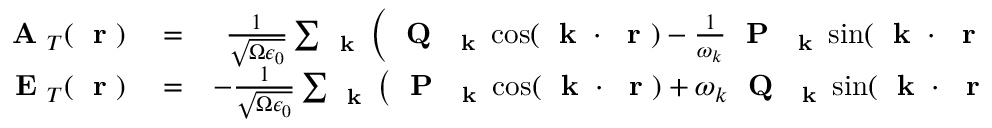Convert formula to latex. <formula><loc_0><loc_0><loc_500><loc_500>\begin{array} { r l r } { A _ { T } ( r ) } & = } & { \frac { 1 } { \sqrt { \Omega \epsilon _ { 0 } } } \sum _ { k } \left ( Q _ { k } \cos ( k \cdot r ) - \frac { 1 } { \omega _ { k } } P _ { k } \sin ( k \cdot r ) \right ) } \\ { E _ { T } ( r ) } & = } & { - \frac { 1 } { \sqrt { \Omega \epsilon _ { 0 } } } \sum _ { k } \left ( P _ { k } \cos ( k \cdot r ) + \omega _ { k } Q _ { k } \sin ( k \cdot r ) \right ) } \end{array}</formula> 